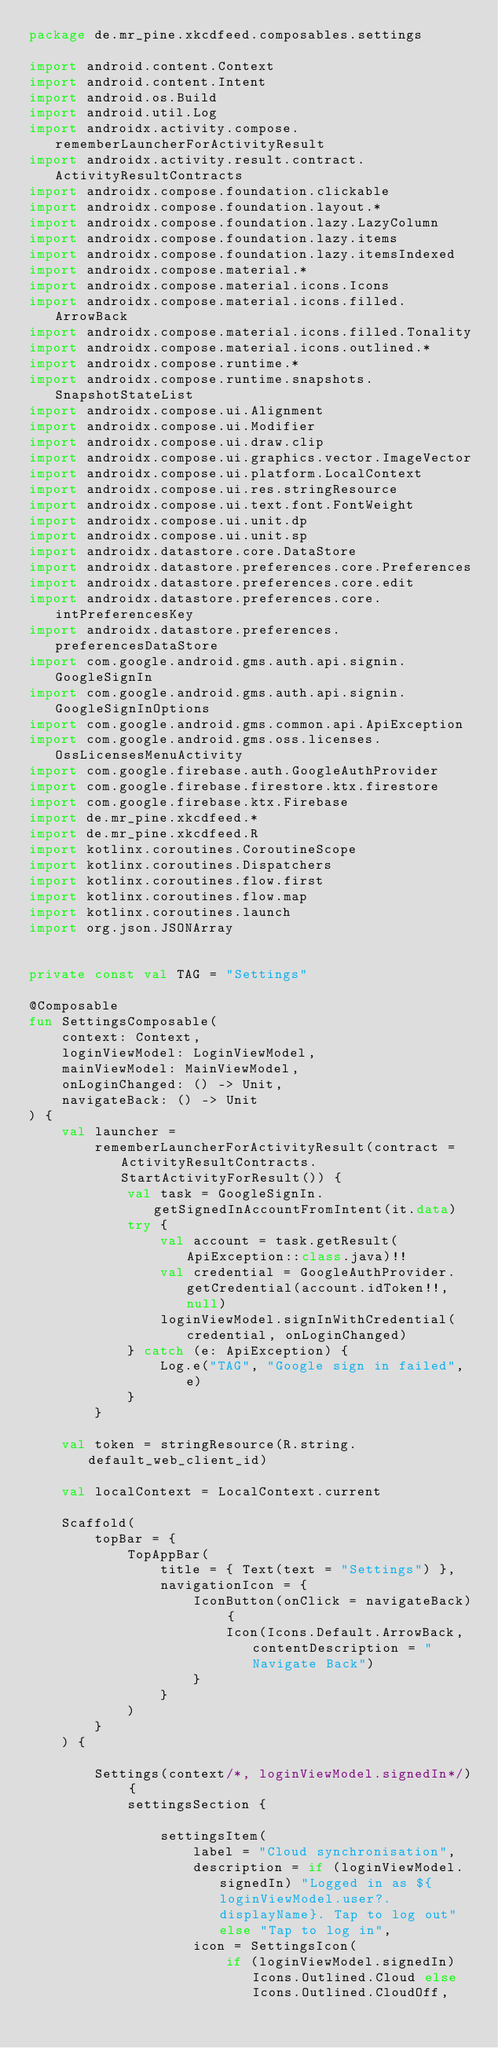Convert code to text. <code><loc_0><loc_0><loc_500><loc_500><_Kotlin_>package de.mr_pine.xkcdfeed.composables.settings

import android.content.Context
import android.content.Intent
import android.os.Build
import android.util.Log
import androidx.activity.compose.rememberLauncherForActivityResult
import androidx.activity.result.contract.ActivityResultContracts
import androidx.compose.foundation.clickable
import androidx.compose.foundation.layout.*
import androidx.compose.foundation.lazy.LazyColumn
import androidx.compose.foundation.lazy.items
import androidx.compose.foundation.lazy.itemsIndexed
import androidx.compose.material.*
import androidx.compose.material.icons.Icons
import androidx.compose.material.icons.filled.ArrowBack
import androidx.compose.material.icons.filled.Tonality
import androidx.compose.material.icons.outlined.*
import androidx.compose.runtime.*
import androidx.compose.runtime.snapshots.SnapshotStateList
import androidx.compose.ui.Alignment
import androidx.compose.ui.Modifier
import androidx.compose.ui.draw.clip
import androidx.compose.ui.graphics.vector.ImageVector
import androidx.compose.ui.platform.LocalContext
import androidx.compose.ui.res.stringResource
import androidx.compose.ui.text.font.FontWeight
import androidx.compose.ui.unit.dp
import androidx.compose.ui.unit.sp
import androidx.datastore.core.DataStore
import androidx.datastore.preferences.core.Preferences
import androidx.datastore.preferences.core.edit
import androidx.datastore.preferences.core.intPreferencesKey
import androidx.datastore.preferences.preferencesDataStore
import com.google.android.gms.auth.api.signin.GoogleSignIn
import com.google.android.gms.auth.api.signin.GoogleSignInOptions
import com.google.android.gms.common.api.ApiException
import com.google.android.gms.oss.licenses.OssLicensesMenuActivity
import com.google.firebase.auth.GoogleAuthProvider
import com.google.firebase.firestore.ktx.firestore
import com.google.firebase.ktx.Firebase
import de.mr_pine.xkcdfeed.*
import de.mr_pine.xkcdfeed.R
import kotlinx.coroutines.CoroutineScope
import kotlinx.coroutines.Dispatchers
import kotlinx.coroutines.flow.first
import kotlinx.coroutines.flow.map
import kotlinx.coroutines.launch
import org.json.JSONArray


private const val TAG = "Settings"

@Composable
fun SettingsComposable(
    context: Context,
    loginViewModel: LoginViewModel,
    mainViewModel: MainViewModel,
    onLoginChanged: () -> Unit,
    navigateBack: () -> Unit
) {
    val launcher =
        rememberLauncherForActivityResult(contract = ActivityResultContracts.StartActivityForResult()) {
            val task = GoogleSignIn.getSignedInAccountFromIntent(it.data)
            try {
                val account = task.getResult(ApiException::class.java)!!
                val credential = GoogleAuthProvider.getCredential(account.idToken!!, null)
                loginViewModel.signInWithCredential(credential, onLoginChanged)
            } catch (e: ApiException) {
                Log.e("TAG", "Google sign in failed", e)
            }
        }

    val token = stringResource(R.string.default_web_client_id)

    val localContext = LocalContext.current

    Scaffold(
        topBar = {
            TopAppBar(
                title = { Text(text = "Settings") },
                navigationIcon = {
                    IconButton(onClick = navigateBack) {
                        Icon(Icons.Default.ArrowBack, contentDescription = "Navigate Back")
                    }
                }
            )
        }
    ) {

        Settings(context/*, loginViewModel.signedIn*/) {
            settingsSection {

                settingsItem(
                    label = "Cloud synchronisation",
                    description = if (loginViewModel.signedIn) "Logged in as ${loginViewModel.user?.displayName}. Tap to log out" else "Tap to log in",
                    icon = SettingsIcon(
                        if (loginViewModel.signedIn) Icons.Outlined.Cloud else Icons.Outlined.CloudOff,</code> 